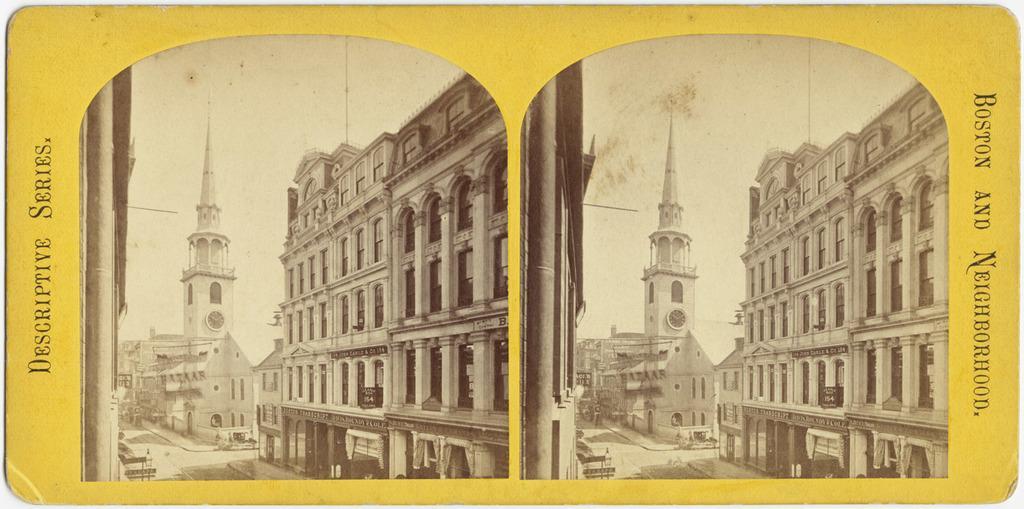Describe this image in one or two sentences. This image consists of a poster. There are two collage image. On the right there are buildings, tower, road, text. On the left there are buildings, tower, road and text. 